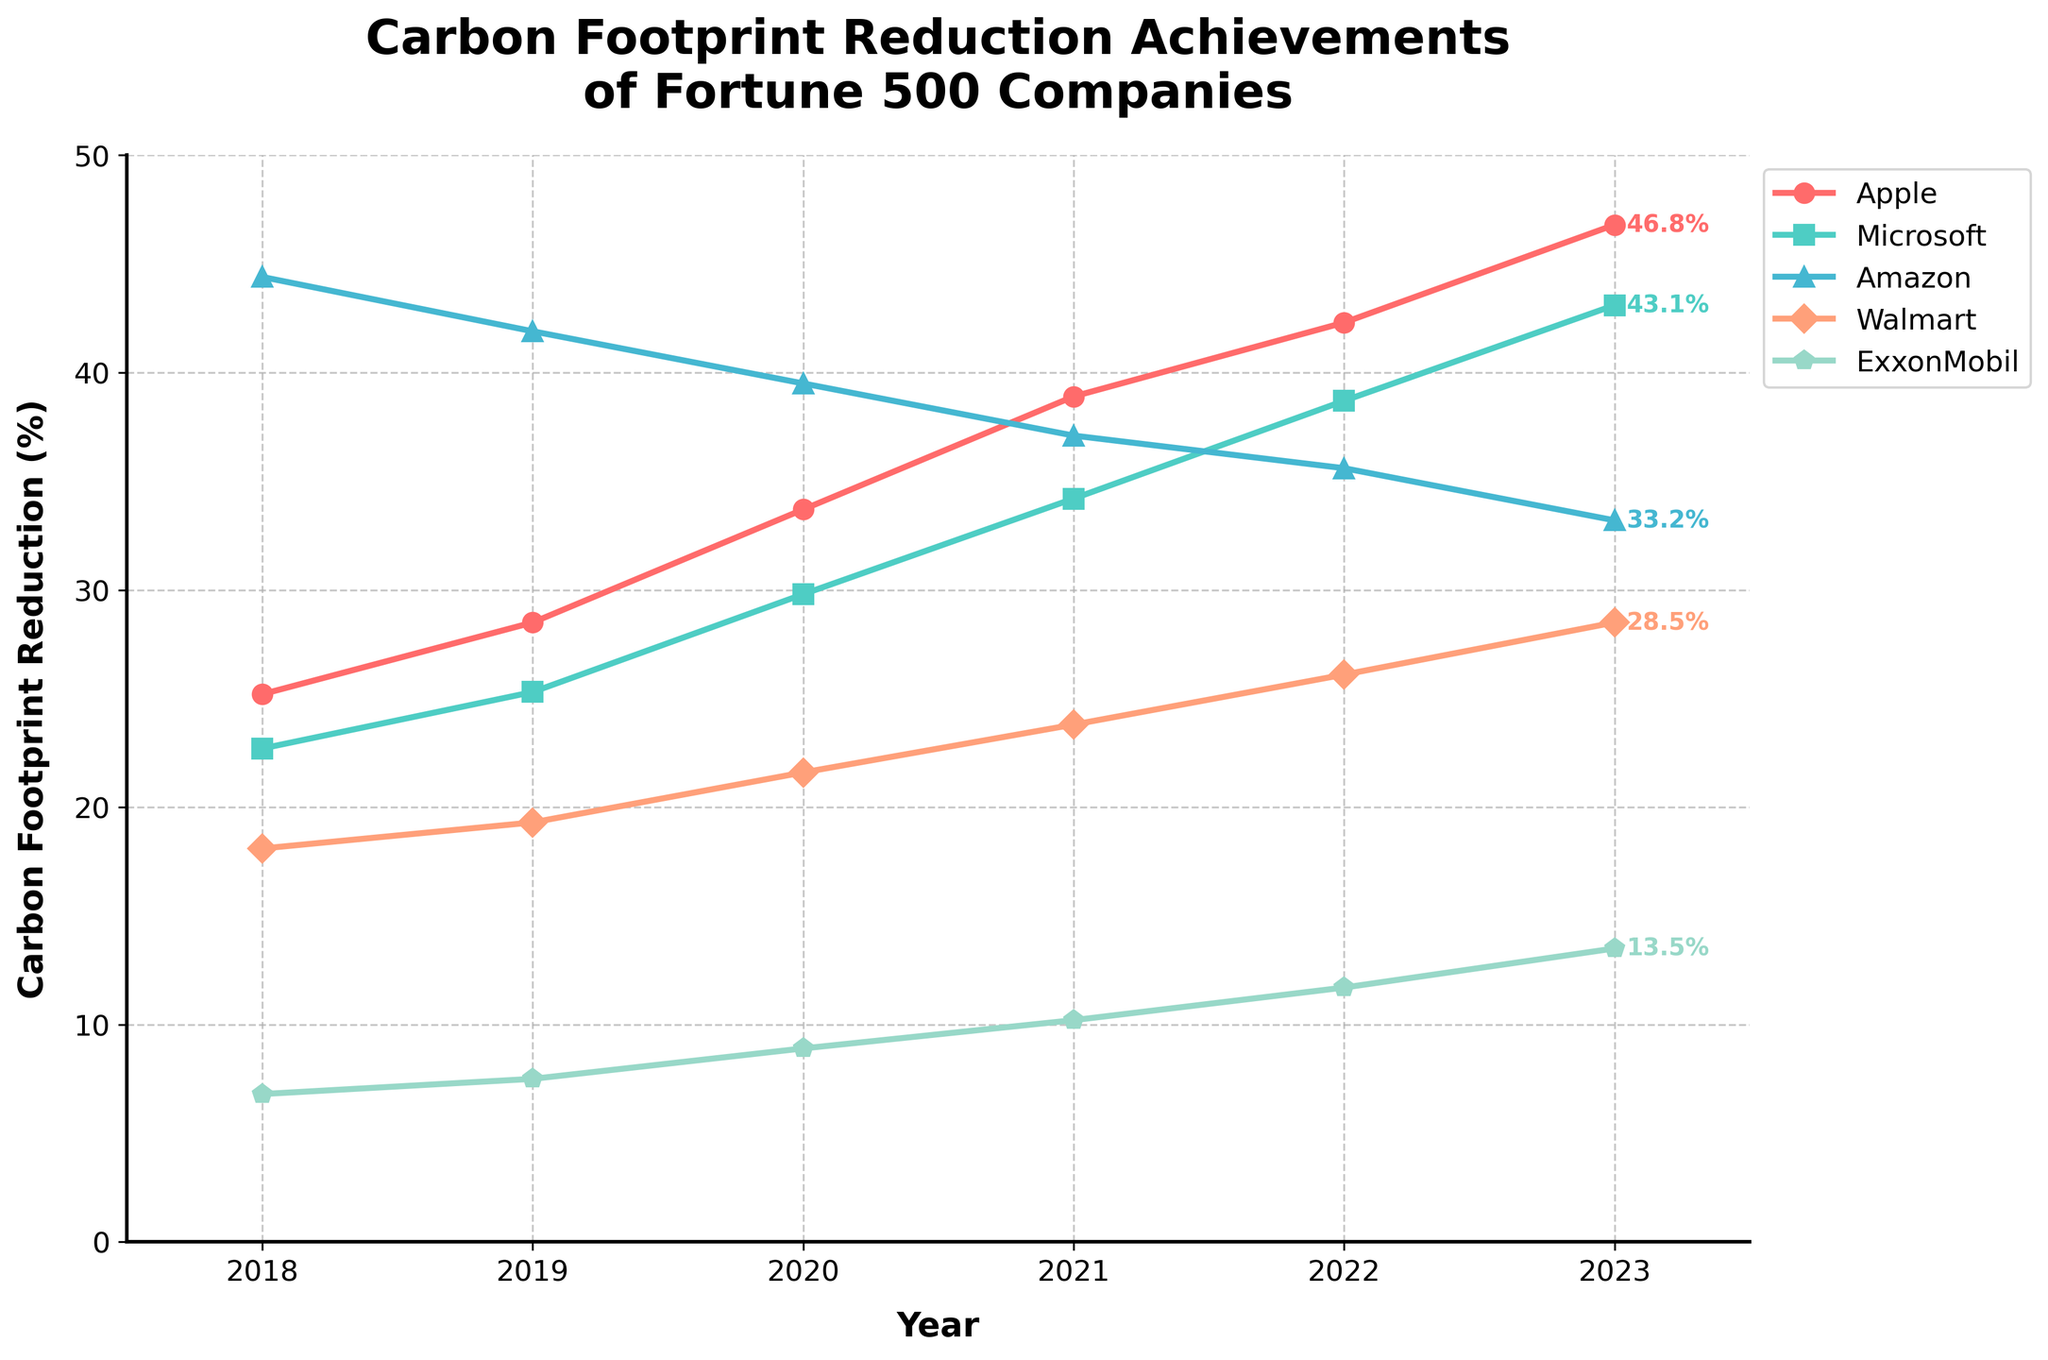What's the overall trend in carbon footprint reduction for Apple between 2018 and 2023? We look at Apple's data from 2018 to 2023 and see that the percentage values consistently increase each year. From 25.2% in 2018 to 46.8% in 2023, it has a clear upward trend.
Answer: Increasing Which company achieved the highest carbon footprint reduction in 2023? By looking at the last data point on the line chart for each company in 2023, we see that Apple has the highest value at 46.8%.
Answer: Apple What is the average carbon footprint reduction for Microsoft from 2018 to 2023? To calculate the average, sum Microsoft's values for these years (22.7, 25.3, 29.8, 34.2, 38.7, 43.1) and divide by the number of years (6). (22.7 + 25.3 + 29.8 + 34.2 + 38.7 + 43.1) / 6 = 193.8 / 6
Answer: 32.3 In which year did Walmart have the greatest increase in carbon footprint reduction compared to the previous year? We calculate the year-to-year differences for Walmart: (19.3 - 18.1 = 1.2), (21.6 - 19.3 = 2.3), (23.8 - 21.6 = 2.2), (26.1 - 23.8 = 2.3), (28.5 - 26.1 = 2.4). The largest increase is in 2023 with a difference of 2.4%.
Answer: 2023 How does Exxon's carbon reduction in 2020 compare to its reduction in 2018 and 2023? We look at the values for Exxon's carbon reduction in 2018 (6.8), 2020 (8.9), and 2023 (13.5). 2020 is higher than 2018 but lower than 2023.
Answer: Higher than 2018, Lower than 2023 What is the total carbon footprint reduction for Amazon over the given years? Summing Amazon's values from 2018 to 2023: 44.4 + 41.9 + 39.5 + 37.1 + 35.6 + 33.2. The sum is 231.7.
Answer: 231.7 What visual marker represents Walmart in the chart? Observing the chart's legend, Walmart is represented by the fourth marker type, a diamond (D).
Answer: Diamond Which company had the smallest overall improvement in carbon footprint reduction from 2018 to 2023? Calculating the change for each company from 2018 to 2023: Apple (46.8 - 25.2 = 21.6), Microsoft (43.1 - 22.7 = 20.4), Amazon (33.2 - 44.4 = 11.2), Walmart (28.5 - 18.1 = 10.4), ExxonMobil (13.5 - 6.8 = 6.7). The smallest improvement is by ExxonMobil, with an increase of 6.7%.
Answer: ExxonMobil 